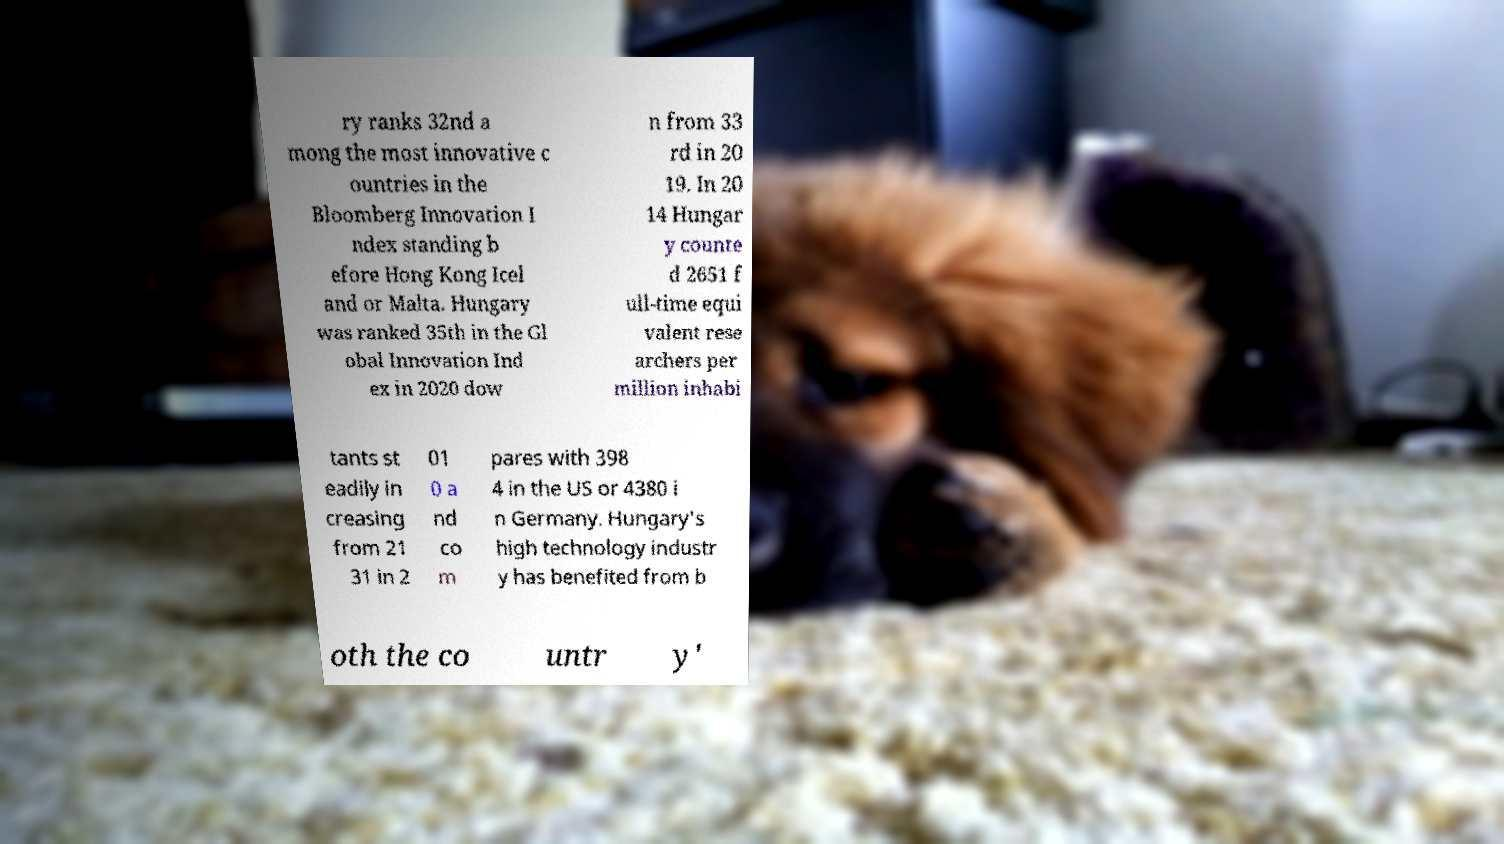What messages or text are displayed in this image? I need them in a readable, typed format. ry ranks 32nd a mong the most innovative c ountries in the Bloomberg Innovation I ndex standing b efore Hong Kong Icel and or Malta. Hungary was ranked 35th in the Gl obal Innovation Ind ex in 2020 dow n from 33 rd in 20 19. In 20 14 Hungar y counte d 2651 f ull-time equi valent rese archers per million inhabi tants st eadily in creasing from 21 31 in 2 01 0 a nd co m pares with 398 4 in the US or 4380 i n Germany. Hungary's high technology industr y has benefited from b oth the co untr y' 